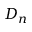Convert formula to latex. <formula><loc_0><loc_0><loc_500><loc_500>D _ { n }</formula> 